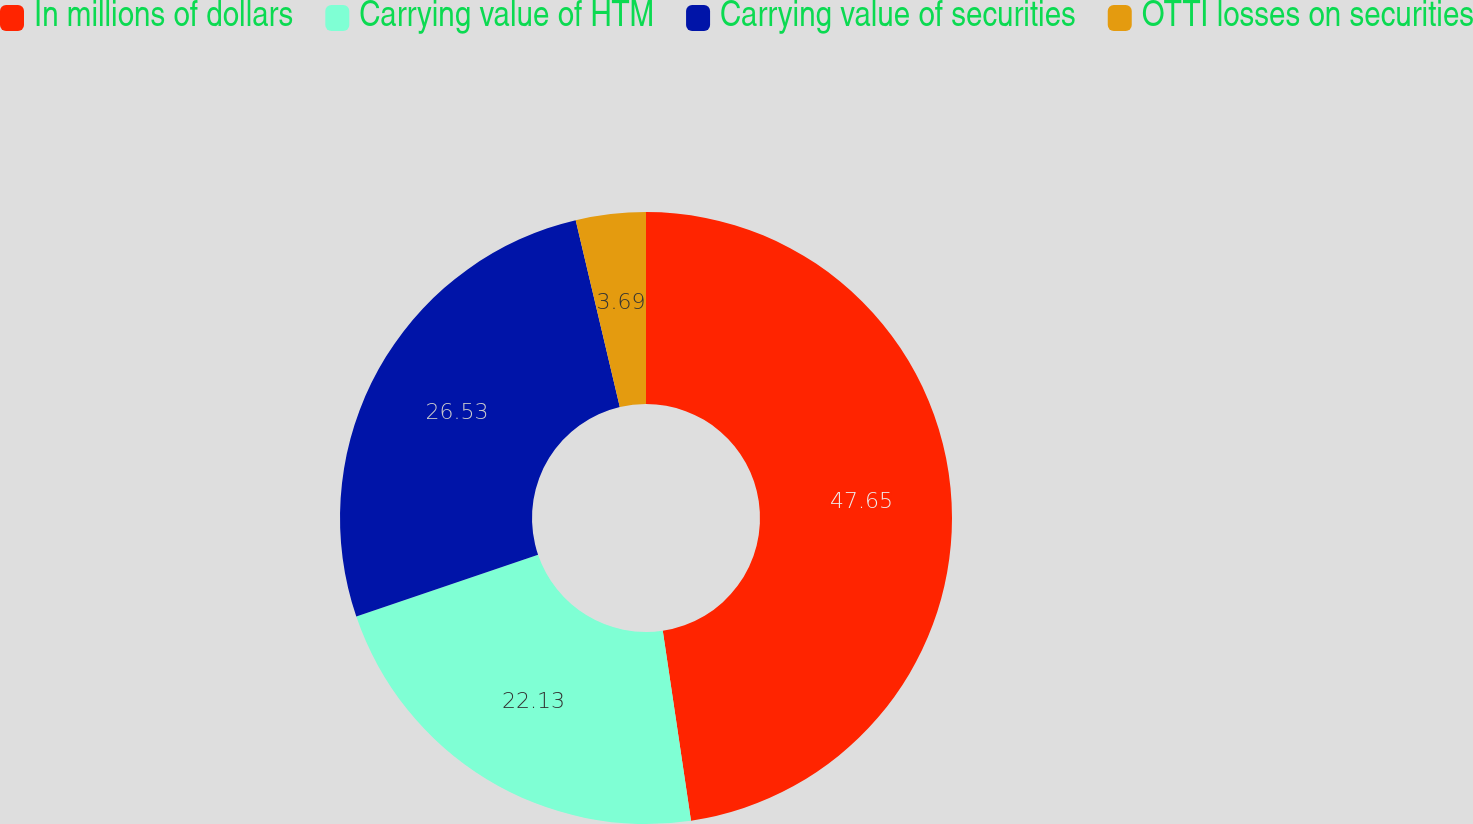Convert chart to OTSL. <chart><loc_0><loc_0><loc_500><loc_500><pie_chart><fcel>In millions of dollars<fcel>Carrying value of HTM<fcel>Carrying value of securities<fcel>OTTI losses on securities<nl><fcel>47.65%<fcel>22.13%<fcel>26.53%<fcel>3.69%<nl></chart> 